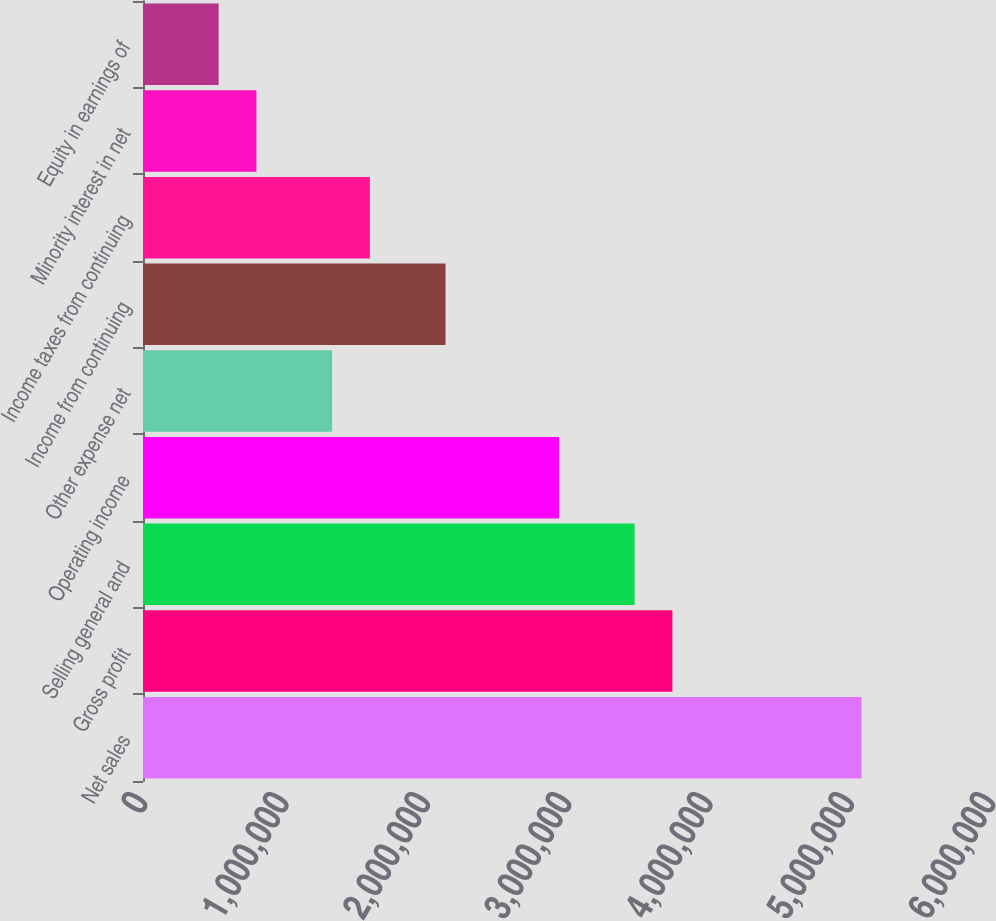Convert chart. <chart><loc_0><loc_0><loc_500><loc_500><bar_chart><fcel>Net sales<fcel>Gross profit<fcel>Selling general and<fcel>Operating income<fcel>Other expense net<fcel>Income from continuing<fcel>Income taxes from continuing<fcel>Minority interest in net<fcel>Equity in earnings of<nl><fcel>5.08372e+06<fcel>3.7459e+06<fcel>3.47834e+06<fcel>2.94321e+06<fcel>1.33782e+06<fcel>2.14052e+06<fcel>1.60539e+06<fcel>802694<fcel>535130<nl></chart> 